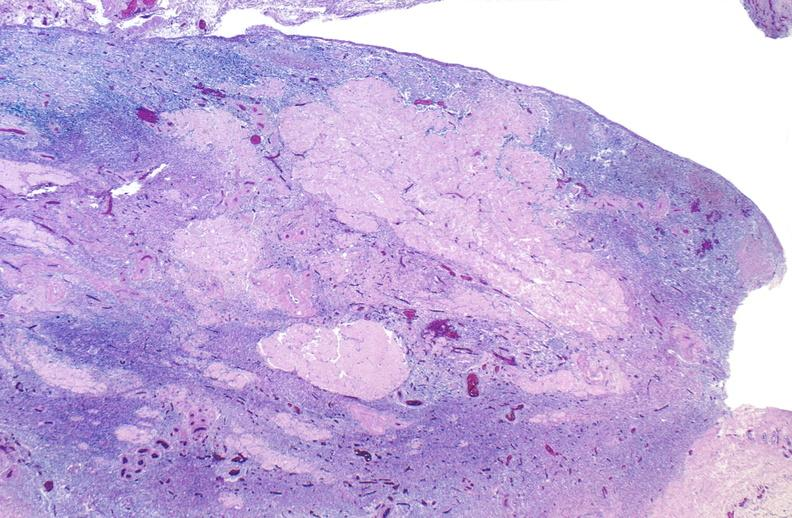what is present?
Answer the question using a single word or phrase. Female reproductive 